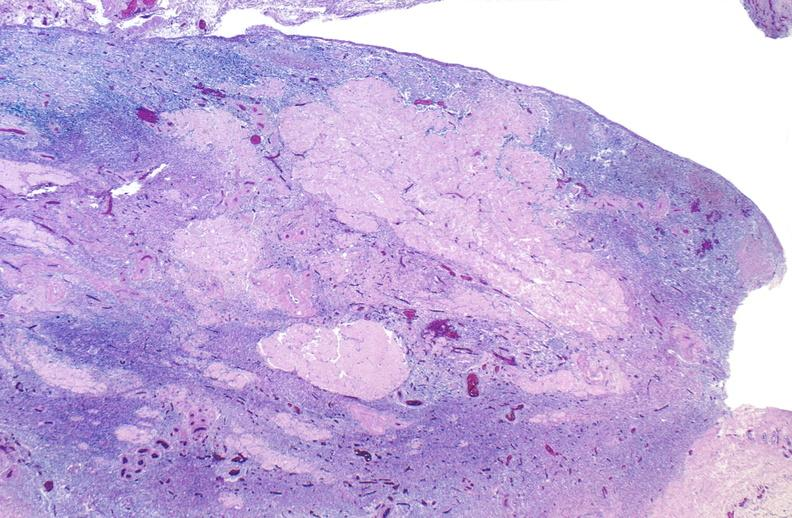what is present?
Answer the question using a single word or phrase. Female reproductive 